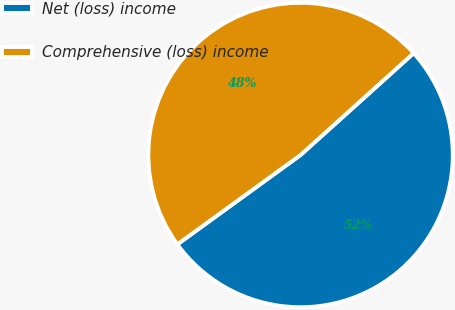Convert chart to OTSL. <chart><loc_0><loc_0><loc_500><loc_500><pie_chart><fcel>Net (loss) income<fcel>Comprehensive (loss) income<nl><fcel>51.68%<fcel>48.32%<nl></chart> 